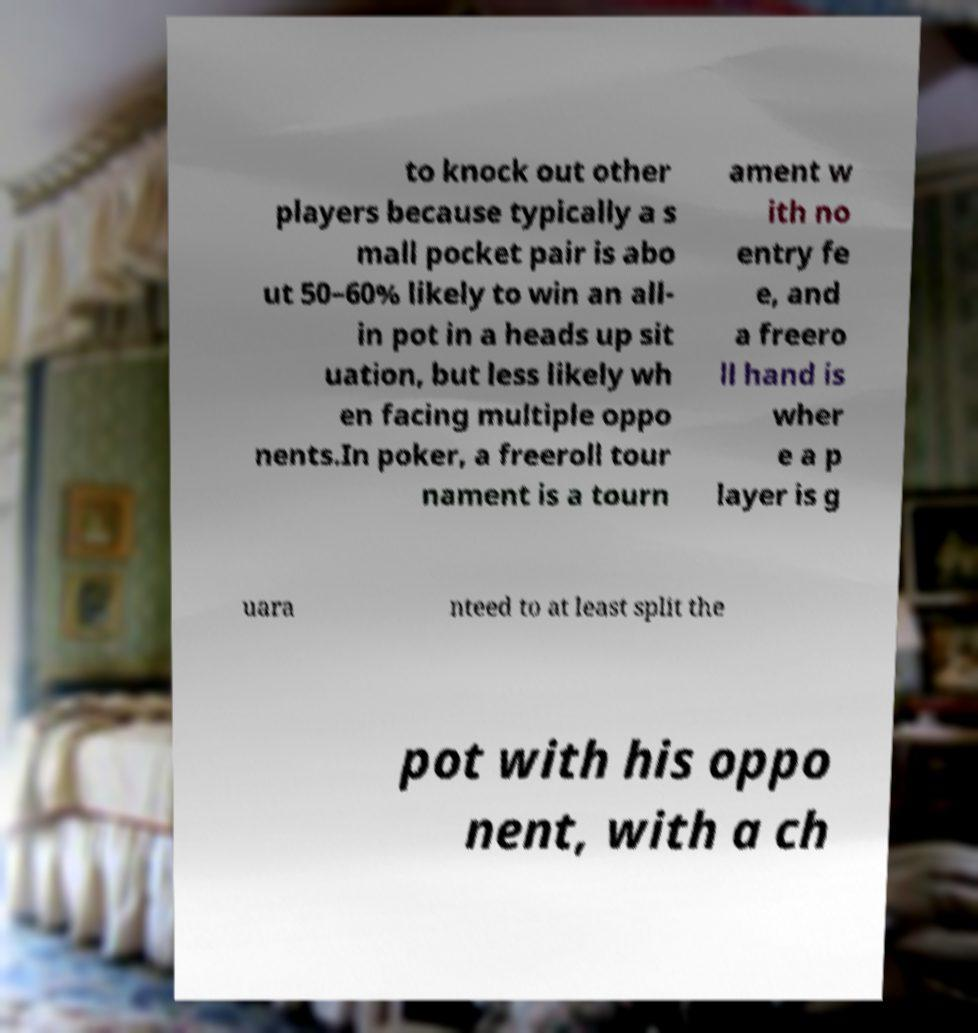For documentation purposes, I need the text within this image transcribed. Could you provide that? to knock out other players because typically a s mall pocket pair is abo ut 50–60% likely to win an all- in pot in a heads up sit uation, but less likely wh en facing multiple oppo nents.In poker, a freeroll tour nament is a tourn ament w ith no entry fe e, and a freero ll hand is wher e a p layer is g uara nteed to at least split the pot with his oppo nent, with a ch 